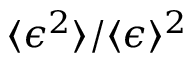Convert formula to latex. <formula><loc_0><loc_0><loc_500><loc_500>\langle \epsilon ^ { 2 } \rangle / \langle \epsilon \rangle ^ { 2 }</formula> 